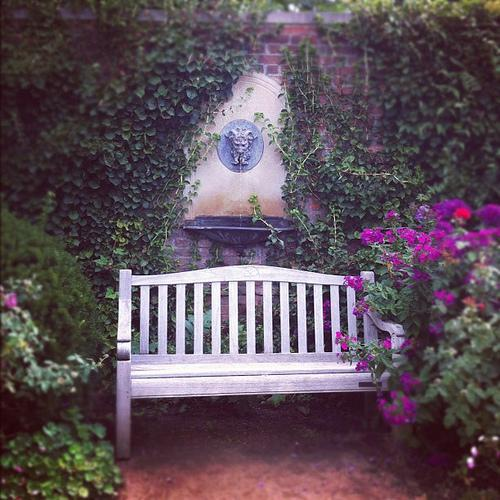Question: what is green on wall?
Choices:
A. Trees.
B. Grass.
C. Moss.
D. Vines.
Answer with the letter. Answer: D Question: why would someone sit on bench?
Choices:
A. Resting.
B. To sleep.
C. To wait for bus.
D. To rest legs.
Answer with the letter. Answer: A Question: who would use the bench?
Choices:
A. Baseball players.
B. People.
C. Fans.
D. People waiting.
Answer with the letter. Answer: B Question: what is purple?
Choices:
A. The lamp.
B. The rug.
C. Flowers.
D. The towel.
Answer with the letter. Answer: C Question: how are the flowers?
Choices:
A. Dried.
B. Wilted.
C. Died.
D. Bloomed.
Answer with the letter. Answer: D 